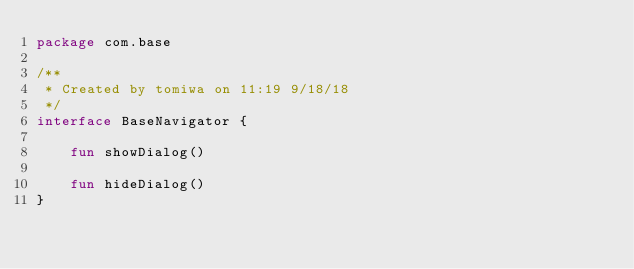Convert code to text. <code><loc_0><loc_0><loc_500><loc_500><_Kotlin_>package com.base

/**
 * Created by tomiwa on 11:19 9/18/18
 */
interface BaseNavigator {

    fun showDialog()

    fun hideDialog()
}</code> 